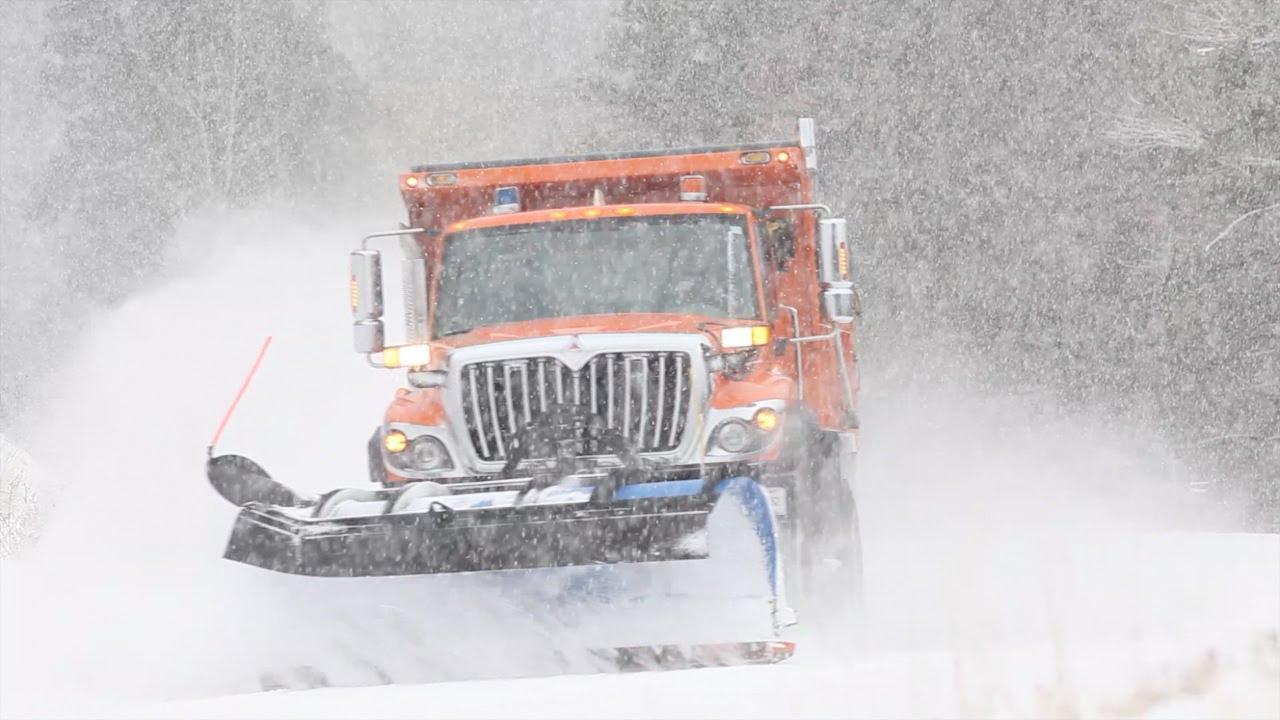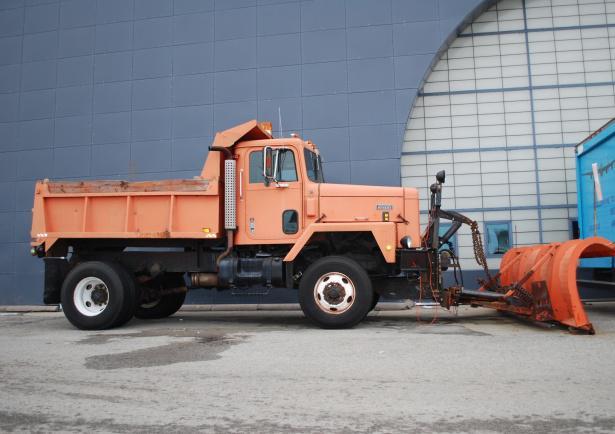The first image is the image on the left, the second image is the image on the right. Given the left and right images, does the statement "An orange truck has a plow on the front of it." hold true? Answer yes or no. Yes. The first image is the image on the left, the second image is the image on the right. Examine the images to the left and right. Is the description "An image features a truck with an orange plow and orange cab." accurate? Answer yes or no. Yes. 